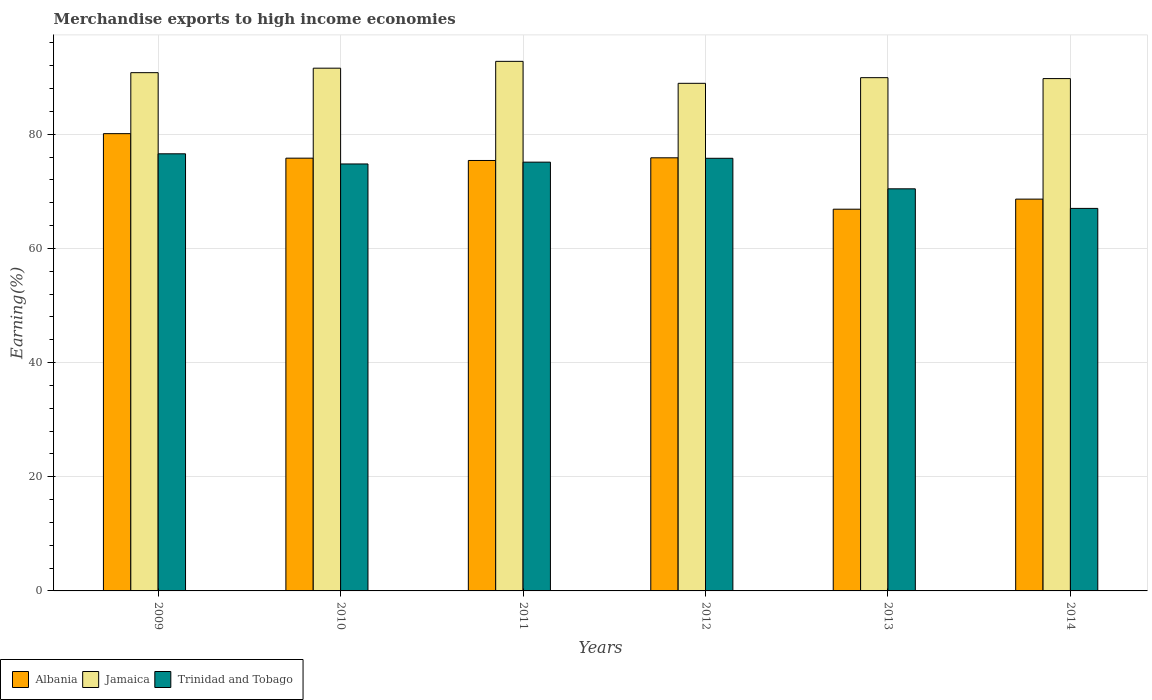How many different coloured bars are there?
Your response must be concise. 3. How many groups of bars are there?
Offer a very short reply. 6. Are the number of bars per tick equal to the number of legend labels?
Offer a very short reply. Yes. How many bars are there on the 2nd tick from the left?
Keep it short and to the point. 3. In how many cases, is the number of bars for a given year not equal to the number of legend labels?
Give a very brief answer. 0. What is the percentage of amount earned from merchandise exports in Albania in 2010?
Your answer should be compact. 75.81. Across all years, what is the maximum percentage of amount earned from merchandise exports in Trinidad and Tobago?
Give a very brief answer. 76.58. Across all years, what is the minimum percentage of amount earned from merchandise exports in Albania?
Provide a succinct answer. 66.87. What is the total percentage of amount earned from merchandise exports in Trinidad and Tobago in the graph?
Provide a short and direct response. 439.73. What is the difference between the percentage of amount earned from merchandise exports in Jamaica in 2012 and that in 2014?
Your response must be concise. -0.83. What is the difference between the percentage of amount earned from merchandise exports in Jamaica in 2011 and the percentage of amount earned from merchandise exports in Trinidad and Tobago in 2013?
Provide a short and direct response. 22.33. What is the average percentage of amount earned from merchandise exports in Jamaica per year?
Offer a very short reply. 90.62. In the year 2012, what is the difference between the percentage of amount earned from merchandise exports in Jamaica and percentage of amount earned from merchandise exports in Albania?
Provide a short and direct response. 13.05. In how many years, is the percentage of amount earned from merchandise exports in Trinidad and Tobago greater than 76 %?
Offer a terse response. 1. What is the ratio of the percentage of amount earned from merchandise exports in Albania in 2011 to that in 2013?
Make the answer very short. 1.13. Is the percentage of amount earned from merchandise exports in Trinidad and Tobago in 2009 less than that in 2013?
Make the answer very short. No. What is the difference between the highest and the second highest percentage of amount earned from merchandise exports in Albania?
Your response must be concise. 4.23. What is the difference between the highest and the lowest percentage of amount earned from merchandise exports in Trinidad and Tobago?
Your response must be concise. 9.56. In how many years, is the percentage of amount earned from merchandise exports in Jamaica greater than the average percentage of amount earned from merchandise exports in Jamaica taken over all years?
Provide a succinct answer. 3. What does the 3rd bar from the left in 2013 represents?
Ensure brevity in your answer.  Trinidad and Tobago. What does the 1st bar from the right in 2014 represents?
Offer a very short reply. Trinidad and Tobago. Is it the case that in every year, the sum of the percentage of amount earned from merchandise exports in Trinidad and Tobago and percentage of amount earned from merchandise exports in Jamaica is greater than the percentage of amount earned from merchandise exports in Albania?
Make the answer very short. Yes. How many years are there in the graph?
Your response must be concise. 6. What is the difference between two consecutive major ticks on the Y-axis?
Make the answer very short. 20. Are the values on the major ticks of Y-axis written in scientific E-notation?
Your response must be concise. No. How many legend labels are there?
Offer a very short reply. 3. How are the legend labels stacked?
Keep it short and to the point. Horizontal. What is the title of the graph?
Ensure brevity in your answer.  Merchandise exports to high income economies. What is the label or title of the X-axis?
Your answer should be compact. Years. What is the label or title of the Y-axis?
Provide a short and direct response. Earning(%). What is the Earning(%) in Albania in 2009?
Provide a succinct answer. 80.11. What is the Earning(%) of Jamaica in 2009?
Your response must be concise. 90.79. What is the Earning(%) of Trinidad and Tobago in 2009?
Your answer should be compact. 76.58. What is the Earning(%) in Albania in 2010?
Ensure brevity in your answer.  75.81. What is the Earning(%) in Jamaica in 2010?
Your answer should be compact. 91.58. What is the Earning(%) of Trinidad and Tobago in 2010?
Ensure brevity in your answer.  74.8. What is the Earning(%) in Albania in 2011?
Keep it short and to the point. 75.41. What is the Earning(%) in Jamaica in 2011?
Offer a very short reply. 92.77. What is the Earning(%) of Trinidad and Tobago in 2011?
Your response must be concise. 75.11. What is the Earning(%) of Albania in 2012?
Your answer should be compact. 75.87. What is the Earning(%) of Jamaica in 2012?
Provide a short and direct response. 88.92. What is the Earning(%) in Trinidad and Tobago in 2012?
Your answer should be compact. 75.79. What is the Earning(%) of Albania in 2013?
Offer a very short reply. 66.87. What is the Earning(%) in Jamaica in 2013?
Give a very brief answer. 89.91. What is the Earning(%) of Trinidad and Tobago in 2013?
Your answer should be very brief. 70.44. What is the Earning(%) of Albania in 2014?
Your answer should be very brief. 68.64. What is the Earning(%) of Jamaica in 2014?
Your response must be concise. 89.75. What is the Earning(%) of Trinidad and Tobago in 2014?
Provide a succinct answer. 67.01. Across all years, what is the maximum Earning(%) of Albania?
Provide a short and direct response. 80.11. Across all years, what is the maximum Earning(%) in Jamaica?
Make the answer very short. 92.77. Across all years, what is the maximum Earning(%) in Trinidad and Tobago?
Offer a terse response. 76.58. Across all years, what is the minimum Earning(%) in Albania?
Your answer should be compact. 66.87. Across all years, what is the minimum Earning(%) in Jamaica?
Provide a succinct answer. 88.92. Across all years, what is the minimum Earning(%) in Trinidad and Tobago?
Make the answer very short. 67.01. What is the total Earning(%) of Albania in the graph?
Keep it short and to the point. 442.71. What is the total Earning(%) of Jamaica in the graph?
Provide a succinct answer. 543.72. What is the total Earning(%) in Trinidad and Tobago in the graph?
Keep it short and to the point. 439.73. What is the difference between the Earning(%) of Albania in 2009 and that in 2010?
Keep it short and to the point. 4.29. What is the difference between the Earning(%) in Jamaica in 2009 and that in 2010?
Give a very brief answer. -0.79. What is the difference between the Earning(%) in Trinidad and Tobago in 2009 and that in 2010?
Offer a terse response. 1.78. What is the difference between the Earning(%) of Albania in 2009 and that in 2011?
Offer a very short reply. 4.7. What is the difference between the Earning(%) in Jamaica in 2009 and that in 2011?
Ensure brevity in your answer.  -1.98. What is the difference between the Earning(%) in Trinidad and Tobago in 2009 and that in 2011?
Provide a short and direct response. 1.46. What is the difference between the Earning(%) in Albania in 2009 and that in 2012?
Your answer should be very brief. 4.23. What is the difference between the Earning(%) in Jamaica in 2009 and that in 2012?
Provide a short and direct response. 1.87. What is the difference between the Earning(%) of Trinidad and Tobago in 2009 and that in 2012?
Provide a succinct answer. 0.79. What is the difference between the Earning(%) of Albania in 2009 and that in 2013?
Ensure brevity in your answer.  13.23. What is the difference between the Earning(%) in Jamaica in 2009 and that in 2013?
Keep it short and to the point. 0.88. What is the difference between the Earning(%) in Trinidad and Tobago in 2009 and that in 2013?
Your response must be concise. 6.13. What is the difference between the Earning(%) in Albania in 2009 and that in 2014?
Your answer should be very brief. 11.47. What is the difference between the Earning(%) of Jamaica in 2009 and that in 2014?
Your response must be concise. 1.04. What is the difference between the Earning(%) in Trinidad and Tobago in 2009 and that in 2014?
Make the answer very short. 9.56. What is the difference between the Earning(%) in Albania in 2010 and that in 2011?
Keep it short and to the point. 0.41. What is the difference between the Earning(%) of Jamaica in 2010 and that in 2011?
Provide a succinct answer. -1.2. What is the difference between the Earning(%) of Trinidad and Tobago in 2010 and that in 2011?
Your answer should be very brief. -0.32. What is the difference between the Earning(%) in Albania in 2010 and that in 2012?
Keep it short and to the point. -0.06. What is the difference between the Earning(%) in Jamaica in 2010 and that in 2012?
Give a very brief answer. 2.65. What is the difference between the Earning(%) of Trinidad and Tobago in 2010 and that in 2012?
Provide a short and direct response. -0.99. What is the difference between the Earning(%) of Albania in 2010 and that in 2013?
Make the answer very short. 8.94. What is the difference between the Earning(%) in Jamaica in 2010 and that in 2013?
Your answer should be very brief. 1.66. What is the difference between the Earning(%) of Trinidad and Tobago in 2010 and that in 2013?
Offer a very short reply. 4.35. What is the difference between the Earning(%) in Albania in 2010 and that in 2014?
Make the answer very short. 7.17. What is the difference between the Earning(%) of Jamaica in 2010 and that in 2014?
Offer a terse response. 1.82. What is the difference between the Earning(%) of Trinidad and Tobago in 2010 and that in 2014?
Offer a very short reply. 7.78. What is the difference between the Earning(%) of Albania in 2011 and that in 2012?
Keep it short and to the point. -0.47. What is the difference between the Earning(%) in Jamaica in 2011 and that in 2012?
Offer a terse response. 3.85. What is the difference between the Earning(%) in Trinidad and Tobago in 2011 and that in 2012?
Your answer should be very brief. -0.67. What is the difference between the Earning(%) in Albania in 2011 and that in 2013?
Offer a terse response. 8.53. What is the difference between the Earning(%) of Jamaica in 2011 and that in 2013?
Offer a very short reply. 2.86. What is the difference between the Earning(%) of Trinidad and Tobago in 2011 and that in 2013?
Make the answer very short. 4.67. What is the difference between the Earning(%) of Albania in 2011 and that in 2014?
Offer a very short reply. 6.77. What is the difference between the Earning(%) in Jamaica in 2011 and that in 2014?
Ensure brevity in your answer.  3.02. What is the difference between the Earning(%) in Trinidad and Tobago in 2011 and that in 2014?
Your response must be concise. 8.1. What is the difference between the Earning(%) of Albania in 2012 and that in 2013?
Give a very brief answer. 9. What is the difference between the Earning(%) of Jamaica in 2012 and that in 2013?
Give a very brief answer. -0.99. What is the difference between the Earning(%) of Trinidad and Tobago in 2012 and that in 2013?
Provide a succinct answer. 5.35. What is the difference between the Earning(%) in Albania in 2012 and that in 2014?
Ensure brevity in your answer.  7.24. What is the difference between the Earning(%) of Jamaica in 2012 and that in 2014?
Provide a short and direct response. -0.83. What is the difference between the Earning(%) in Trinidad and Tobago in 2012 and that in 2014?
Make the answer very short. 8.78. What is the difference between the Earning(%) of Albania in 2013 and that in 2014?
Keep it short and to the point. -1.77. What is the difference between the Earning(%) in Jamaica in 2013 and that in 2014?
Offer a very short reply. 0.16. What is the difference between the Earning(%) in Trinidad and Tobago in 2013 and that in 2014?
Your answer should be compact. 3.43. What is the difference between the Earning(%) of Albania in 2009 and the Earning(%) of Jamaica in 2010?
Ensure brevity in your answer.  -11.47. What is the difference between the Earning(%) in Albania in 2009 and the Earning(%) in Trinidad and Tobago in 2010?
Offer a very short reply. 5.31. What is the difference between the Earning(%) in Jamaica in 2009 and the Earning(%) in Trinidad and Tobago in 2010?
Provide a short and direct response. 15.99. What is the difference between the Earning(%) of Albania in 2009 and the Earning(%) of Jamaica in 2011?
Give a very brief answer. -12.66. What is the difference between the Earning(%) in Albania in 2009 and the Earning(%) in Trinidad and Tobago in 2011?
Your answer should be compact. 4.99. What is the difference between the Earning(%) of Jamaica in 2009 and the Earning(%) of Trinidad and Tobago in 2011?
Give a very brief answer. 15.68. What is the difference between the Earning(%) of Albania in 2009 and the Earning(%) of Jamaica in 2012?
Keep it short and to the point. -8.82. What is the difference between the Earning(%) of Albania in 2009 and the Earning(%) of Trinidad and Tobago in 2012?
Provide a succinct answer. 4.32. What is the difference between the Earning(%) of Jamaica in 2009 and the Earning(%) of Trinidad and Tobago in 2012?
Offer a terse response. 15. What is the difference between the Earning(%) in Albania in 2009 and the Earning(%) in Jamaica in 2013?
Offer a very short reply. -9.81. What is the difference between the Earning(%) of Albania in 2009 and the Earning(%) of Trinidad and Tobago in 2013?
Your answer should be compact. 9.66. What is the difference between the Earning(%) of Jamaica in 2009 and the Earning(%) of Trinidad and Tobago in 2013?
Keep it short and to the point. 20.35. What is the difference between the Earning(%) in Albania in 2009 and the Earning(%) in Jamaica in 2014?
Your answer should be compact. -9.65. What is the difference between the Earning(%) in Albania in 2009 and the Earning(%) in Trinidad and Tobago in 2014?
Give a very brief answer. 13.09. What is the difference between the Earning(%) of Jamaica in 2009 and the Earning(%) of Trinidad and Tobago in 2014?
Offer a very short reply. 23.78. What is the difference between the Earning(%) of Albania in 2010 and the Earning(%) of Jamaica in 2011?
Keep it short and to the point. -16.96. What is the difference between the Earning(%) in Albania in 2010 and the Earning(%) in Trinidad and Tobago in 2011?
Give a very brief answer. 0.7. What is the difference between the Earning(%) of Jamaica in 2010 and the Earning(%) of Trinidad and Tobago in 2011?
Your answer should be very brief. 16.46. What is the difference between the Earning(%) of Albania in 2010 and the Earning(%) of Jamaica in 2012?
Your answer should be compact. -13.11. What is the difference between the Earning(%) in Albania in 2010 and the Earning(%) in Trinidad and Tobago in 2012?
Your response must be concise. 0.02. What is the difference between the Earning(%) of Jamaica in 2010 and the Earning(%) of Trinidad and Tobago in 2012?
Ensure brevity in your answer.  15.79. What is the difference between the Earning(%) in Albania in 2010 and the Earning(%) in Jamaica in 2013?
Offer a terse response. -14.1. What is the difference between the Earning(%) of Albania in 2010 and the Earning(%) of Trinidad and Tobago in 2013?
Provide a short and direct response. 5.37. What is the difference between the Earning(%) in Jamaica in 2010 and the Earning(%) in Trinidad and Tobago in 2013?
Offer a very short reply. 21.13. What is the difference between the Earning(%) in Albania in 2010 and the Earning(%) in Jamaica in 2014?
Provide a short and direct response. -13.94. What is the difference between the Earning(%) of Albania in 2010 and the Earning(%) of Trinidad and Tobago in 2014?
Your answer should be very brief. 8.8. What is the difference between the Earning(%) of Jamaica in 2010 and the Earning(%) of Trinidad and Tobago in 2014?
Your answer should be very brief. 24.56. What is the difference between the Earning(%) of Albania in 2011 and the Earning(%) of Jamaica in 2012?
Provide a succinct answer. -13.52. What is the difference between the Earning(%) of Albania in 2011 and the Earning(%) of Trinidad and Tobago in 2012?
Provide a short and direct response. -0.38. What is the difference between the Earning(%) of Jamaica in 2011 and the Earning(%) of Trinidad and Tobago in 2012?
Give a very brief answer. 16.98. What is the difference between the Earning(%) in Albania in 2011 and the Earning(%) in Jamaica in 2013?
Your response must be concise. -14.51. What is the difference between the Earning(%) in Albania in 2011 and the Earning(%) in Trinidad and Tobago in 2013?
Provide a succinct answer. 4.96. What is the difference between the Earning(%) of Jamaica in 2011 and the Earning(%) of Trinidad and Tobago in 2013?
Give a very brief answer. 22.33. What is the difference between the Earning(%) of Albania in 2011 and the Earning(%) of Jamaica in 2014?
Your answer should be very brief. -14.35. What is the difference between the Earning(%) of Albania in 2011 and the Earning(%) of Trinidad and Tobago in 2014?
Offer a terse response. 8.39. What is the difference between the Earning(%) of Jamaica in 2011 and the Earning(%) of Trinidad and Tobago in 2014?
Provide a short and direct response. 25.76. What is the difference between the Earning(%) in Albania in 2012 and the Earning(%) in Jamaica in 2013?
Make the answer very short. -14.04. What is the difference between the Earning(%) in Albania in 2012 and the Earning(%) in Trinidad and Tobago in 2013?
Your answer should be very brief. 5.43. What is the difference between the Earning(%) of Jamaica in 2012 and the Earning(%) of Trinidad and Tobago in 2013?
Offer a terse response. 18.48. What is the difference between the Earning(%) of Albania in 2012 and the Earning(%) of Jamaica in 2014?
Offer a terse response. -13.88. What is the difference between the Earning(%) of Albania in 2012 and the Earning(%) of Trinidad and Tobago in 2014?
Ensure brevity in your answer.  8.86. What is the difference between the Earning(%) of Jamaica in 2012 and the Earning(%) of Trinidad and Tobago in 2014?
Give a very brief answer. 21.91. What is the difference between the Earning(%) of Albania in 2013 and the Earning(%) of Jamaica in 2014?
Offer a very short reply. -22.88. What is the difference between the Earning(%) of Albania in 2013 and the Earning(%) of Trinidad and Tobago in 2014?
Keep it short and to the point. -0.14. What is the difference between the Earning(%) of Jamaica in 2013 and the Earning(%) of Trinidad and Tobago in 2014?
Make the answer very short. 22.9. What is the average Earning(%) in Albania per year?
Offer a terse response. 73.78. What is the average Earning(%) in Jamaica per year?
Give a very brief answer. 90.62. What is the average Earning(%) of Trinidad and Tobago per year?
Your answer should be very brief. 73.29. In the year 2009, what is the difference between the Earning(%) in Albania and Earning(%) in Jamaica?
Give a very brief answer. -10.68. In the year 2009, what is the difference between the Earning(%) in Albania and Earning(%) in Trinidad and Tobago?
Your answer should be very brief. 3.53. In the year 2009, what is the difference between the Earning(%) of Jamaica and Earning(%) of Trinidad and Tobago?
Offer a very short reply. 14.21. In the year 2010, what is the difference between the Earning(%) in Albania and Earning(%) in Jamaica?
Provide a succinct answer. -15.76. In the year 2010, what is the difference between the Earning(%) in Albania and Earning(%) in Trinidad and Tobago?
Your response must be concise. 1.02. In the year 2010, what is the difference between the Earning(%) in Jamaica and Earning(%) in Trinidad and Tobago?
Ensure brevity in your answer.  16.78. In the year 2011, what is the difference between the Earning(%) in Albania and Earning(%) in Jamaica?
Give a very brief answer. -17.37. In the year 2011, what is the difference between the Earning(%) in Albania and Earning(%) in Trinidad and Tobago?
Offer a terse response. 0.29. In the year 2011, what is the difference between the Earning(%) in Jamaica and Earning(%) in Trinidad and Tobago?
Offer a very short reply. 17.66. In the year 2012, what is the difference between the Earning(%) in Albania and Earning(%) in Jamaica?
Provide a succinct answer. -13.05. In the year 2012, what is the difference between the Earning(%) of Albania and Earning(%) of Trinidad and Tobago?
Your answer should be compact. 0.09. In the year 2012, what is the difference between the Earning(%) of Jamaica and Earning(%) of Trinidad and Tobago?
Make the answer very short. 13.13. In the year 2013, what is the difference between the Earning(%) in Albania and Earning(%) in Jamaica?
Your answer should be very brief. -23.04. In the year 2013, what is the difference between the Earning(%) in Albania and Earning(%) in Trinidad and Tobago?
Give a very brief answer. -3.57. In the year 2013, what is the difference between the Earning(%) of Jamaica and Earning(%) of Trinidad and Tobago?
Provide a succinct answer. 19.47. In the year 2014, what is the difference between the Earning(%) of Albania and Earning(%) of Jamaica?
Offer a terse response. -21.11. In the year 2014, what is the difference between the Earning(%) of Albania and Earning(%) of Trinidad and Tobago?
Your response must be concise. 1.63. In the year 2014, what is the difference between the Earning(%) of Jamaica and Earning(%) of Trinidad and Tobago?
Provide a short and direct response. 22.74. What is the ratio of the Earning(%) in Albania in 2009 to that in 2010?
Your answer should be compact. 1.06. What is the ratio of the Earning(%) of Trinidad and Tobago in 2009 to that in 2010?
Ensure brevity in your answer.  1.02. What is the ratio of the Earning(%) in Albania in 2009 to that in 2011?
Your answer should be compact. 1.06. What is the ratio of the Earning(%) of Jamaica in 2009 to that in 2011?
Provide a short and direct response. 0.98. What is the ratio of the Earning(%) in Trinidad and Tobago in 2009 to that in 2011?
Ensure brevity in your answer.  1.02. What is the ratio of the Earning(%) of Albania in 2009 to that in 2012?
Your response must be concise. 1.06. What is the ratio of the Earning(%) in Trinidad and Tobago in 2009 to that in 2012?
Give a very brief answer. 1.01. What is the ratio of the Earning(%) of Albania in 2009 to that in 2013?
Your answer should be compact. 1.2. What is the ratio of the Earning(%) of Jamaica in 2009 to that in 2013?
Provide a succinct answer. 1.01. What is the ratio of the Earning(%) in Trinidad and Tobago in 2009 to that in 2013?
Give a very brief answer. 1.09. What is the ratio of the Earning(%) of Albania in 2009 to that in 2014?
Your response must be concise. 1.17. What is the ratio of the Earning(%) of Jamaica in 2009 to that in 2014?
Make the answer very short. 1.01. What is the ratio of the Earning(%) of Trinidad and Tobago in 2009 to that in 2014?
Offer a terse response. 1.14. What is the ratio of the Earning(%) of Albania in 2010 to that in 2011?
Provide a short and direct response. 1.01. What is the ratio of the Earning(%) of Jamaica in 2010 to that in 2011?
Provide a succinct answer. 0.99. What is the ratio of the Earning(%) in Trinidad and Tobago in 2010 to that in 2011?
Your answer should be very brief. 1. What is the ratio of the Earning(%) in Albania in 2010 to that in 2012?
Your response must be concise. 1. What is the ratio of the Earning(%) in Jamaica in 2010 to that in 2012?
Offer a terse response. 1.03. What is the ratio of the Earning(%) in Trinidad and Tobago in 2010 to that in 2012?
Make the answer very short. 0.99. What is the ratio of the Earning(%) of Albania in 2010 to that in 2013?
Your response must be concise. 1.13. What is the ratio of the Earning(%) of Jamaica in 2010 to that in 2013?
Your answer should be very brief. 1.02. What is the ratio of the Earning(%) in Trinidad and Tobago in 2010 to that in 2013?
Provide a succinct answer. 1.06. What is the ratio of the Earning(%) of Albania in 2010 to that in 2014?
Offer a terse response. 1.1. What is the ratio of the Earning(%) in Jamaica in 2010 to that in 2014?
Provide a succinct answer. 1.02. What is the ratio of the Earning(%) of Trinidad and Tobago in 2010 to that in 2014?
Provide a short and direct response. 1.12. What is the ratio of the Earning(%) in Jamaica in 2011 to that in 2012?
Keep it short and to the point. 1.04. What is the ratio of the Earning(%) in Albania in 2011 to that in 2013?
Provide a short and direct response. 1.13. What is the ratio of the Earning(%) of Jamaica in 2011 to that in 2013?
Give a very brief answer. 1.03. What is the ratio of the Earning(%) of Trinidad and Tobago in 2011 to that in 2013?
Make the answer very short. 1.07. What is the ratio of the Earning(%) of Albania in 2011 to that in 2014?
Offer a terse response. 1.1. What is the ratio of the Earning(%) in Jamaica in 2011 to that in 2014?
Ensure brevity in your answer.  1.03. What is the ratio of the Earning(%) of Trinidad and Tobago in 2011 to that in 2014?
Give a very brief answer. 1.12. What is the ratio of the Earning(%) in Albania in 2012 to that in 2013?
Your response must be concise. 1.13. What is the ratio of the Earning(%) of Jamaica in 2012 to that in 2013?
Provide a short and direct response. 0.99. What is the ratio of the Earning(%) in Trinidad and Tobago in 2012 to that in 2013?
Give a very brief answer. 1.08. What is the ratio of the Earning(%) in Albania in 2012 to that in 2014?
Make the answer very short. 1.11. What is the ratio of the Earning(%) of Trinidad and Tobago in 2012 to that in 2014?
Your answer should be very brief. 1.13. What is the ratio of the Earning(%) in Albania in 2013 to that in 2014?
Give a very brief answer. 0.97. What is the ratio of the Earning(%) of Trinidad and Tobago in 2013 to that in 2014?
Ensure brevity in your answer.  1.05. What is the difference between the highest and the second highest Earning(%) of Albania?
Provide a short and direct response. 4.23. What is the difference between the highest and the second highest Earning(%) in Jamaica?
Make the answer very short. 1.2. What is the difference between the highest and the second highest Earning(%) of Trinidad and Tobago?
Your answer should be very brief. 0.79. What is the difference between the highest and the lowest Earning(%) in Albania?
Your answer should be very brief. 13.23. What is the difference between the highest and the lowest Earning(%) of Jamaica?
Offer a terse response. 3.85. What is the difference between the highest and the lowest Earning(%) of Trinidad and Tobago?
Your answer should be very brief. 9.56. 